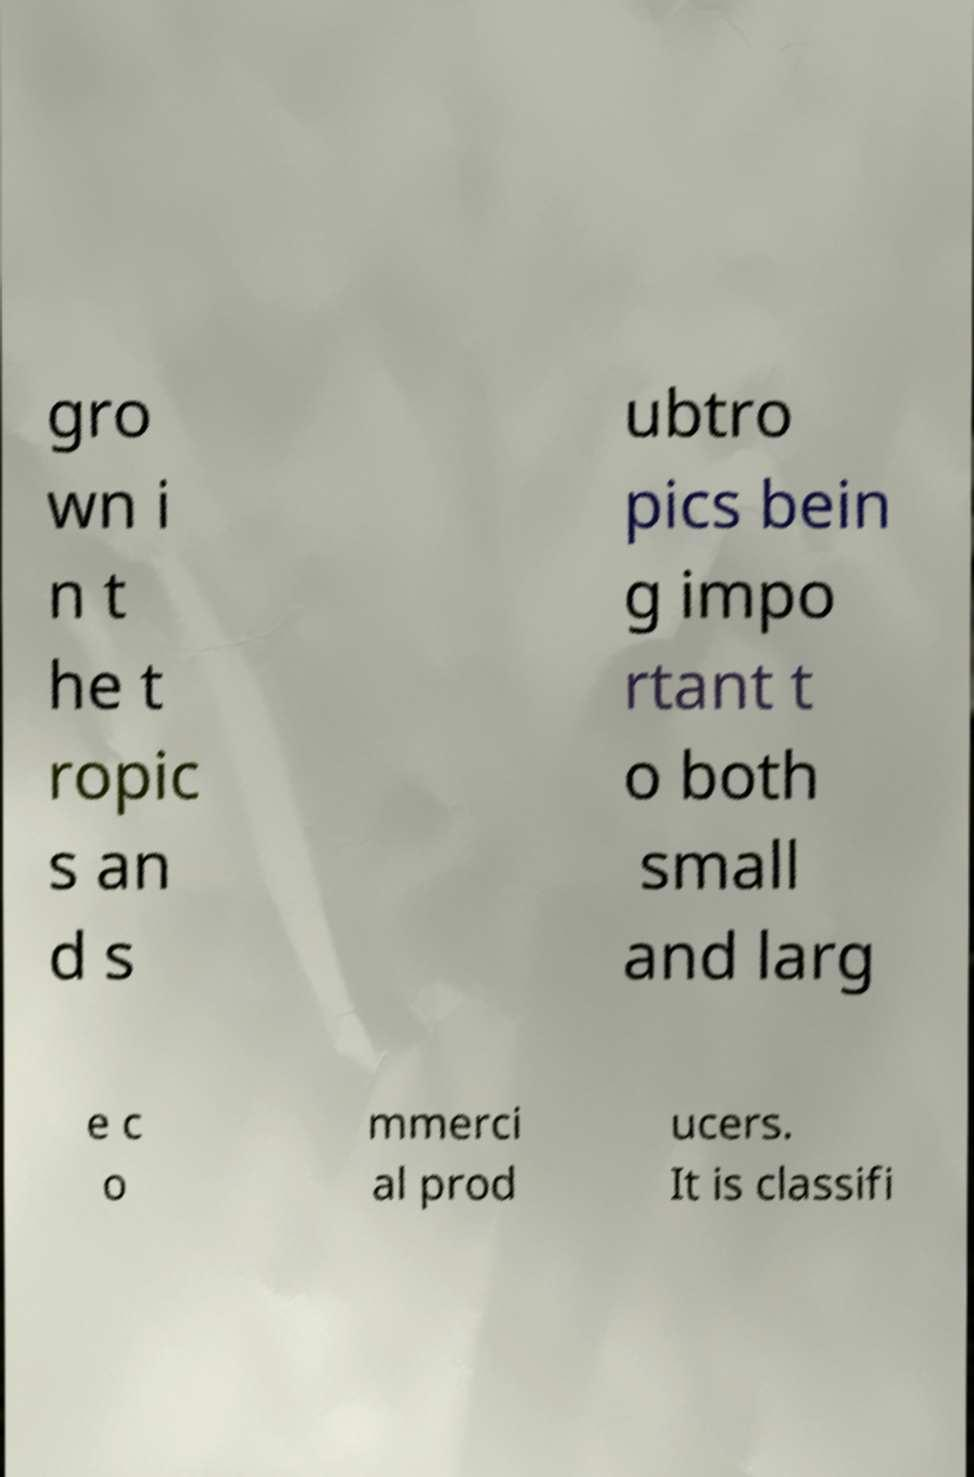Please identify and transcribe the text found in this image. gro wn i n t he t ropic s an d s ubtro pics bein g impo rtant t o both small and larg e c o mmerci al prod ucers. It is classifi 